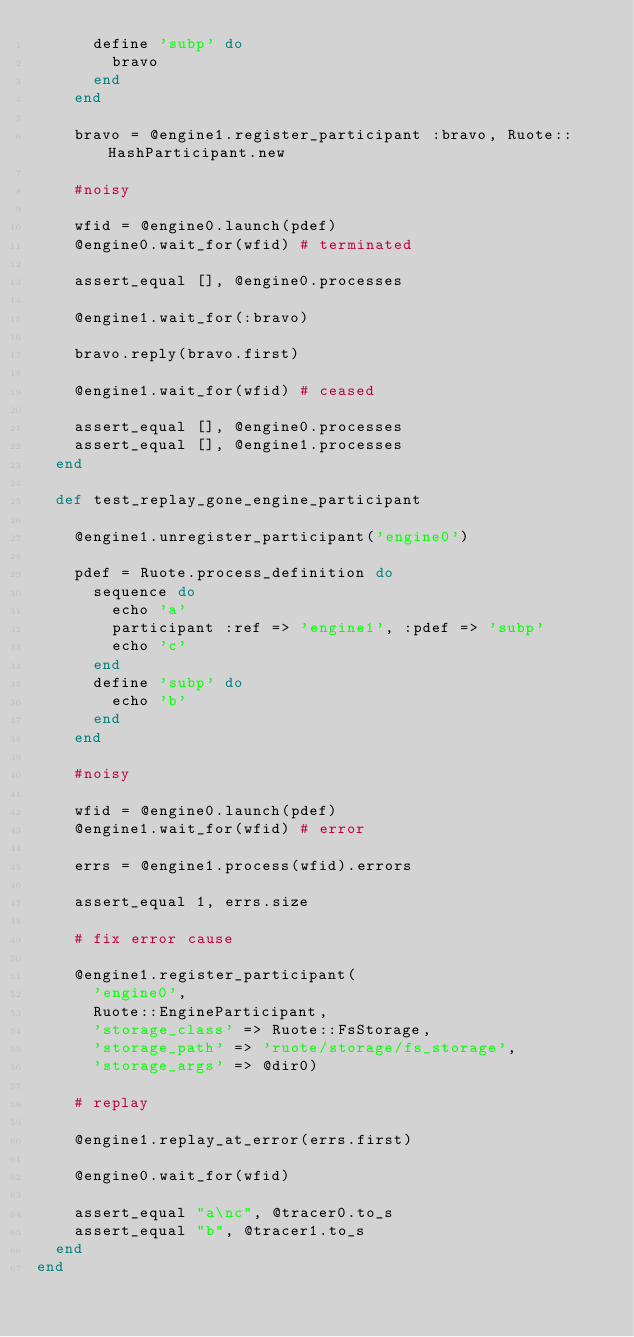<code> <loc_0><loc_0><loc_500><loc_500><_Ruby_>      define 'subp' do
        bravo
      end
    end

    bravo = @engine1.register_participant :bravo, Ruote::HashParticipant.new

    #noisy

    wfid = @engine0.launch(pdef)
    @engine0.wait_for(wfid) # terminated

    assert_equal [], @engine0.processes

    @engine1.wait_for(:bravo)

    bravo.reply(bravo.first)

    @engine1.wait_for(wfid) # ceased

    assert_equal [], @engine0.processes
    assert_equal [], @engine1.processes
  end

  def test_replay_gone_engine_participant

    @engine1.unregister_participant('engine0')

    pdef = Ruote.process_definition do
      sequence do
        echo 'a'
        participant :ref => 'engine1', :pdef => 'subp'
        echo 'c'
      end
      define 'subp' do
        echo 'b'
      end
    end

    #noisy

    wfid = @engine0.launch(pdef)
    @engine1.wait_for(wfid) # error

    errs = @engine1.process(wfid).errors

    assert_equal 1, errs.size

    # fix error cause

    @engine1.register_participant(
      'engine0',
      Ruote::EngineParticipant,
      'storage_class' => Ruote::FsStorage,
      'storage_path' => 'ruote/storage/fs_storage',
      'storage_args' => @dir0)

    # replay

    @engine1.replay_at_error(errs.first)

    @engine0.wait_for(wfid)

    assert_equal "a\nc", @tracer0.to_s
    assert_equal "b", @tracer1.to_s
  end
end

</code> 